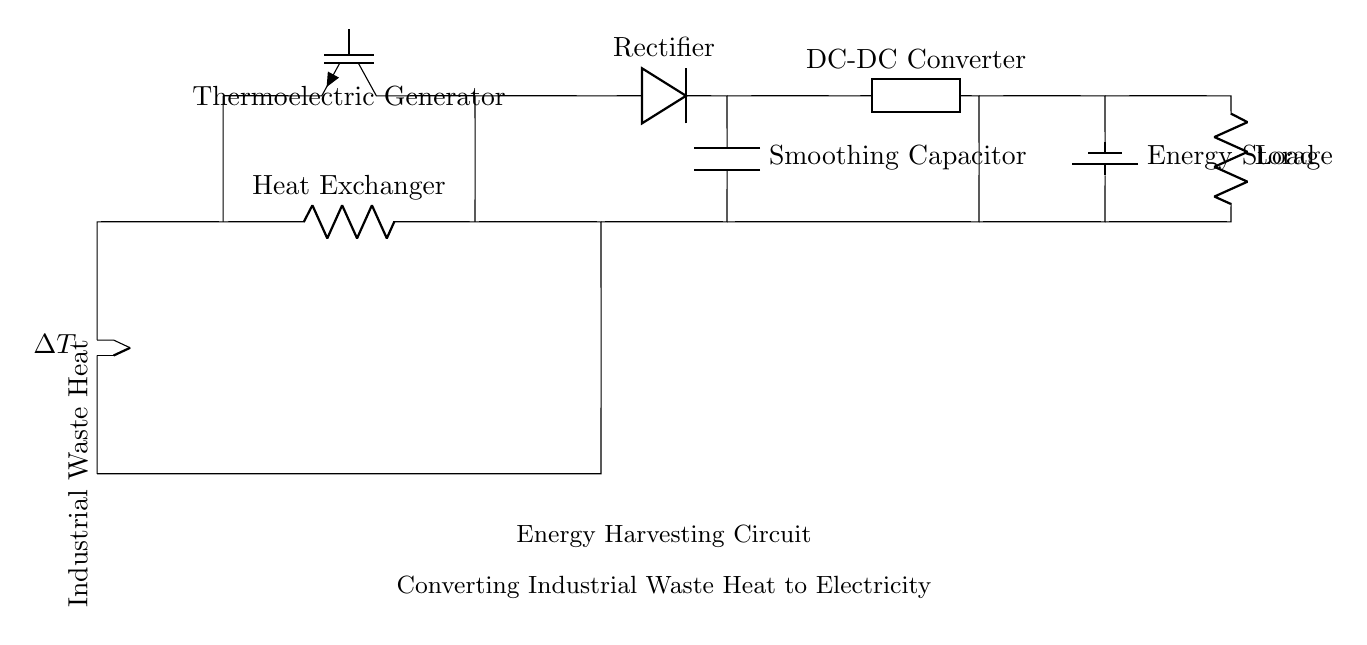What is the primary energy source for this circuit? The primary energy source is industrial waste heat, indicated by the label "Industrial Waste Heat" connected to the thermocouple.
Answer: industrial waste heat What component converts heat into electricity? The component that converts heat into electricity is the thermoelectric generator, which is labeled as such in the circuit.
Answer: thermoelectric generator What is the role of the rectifier in this circuit? The rectifier's role is to convert the alternating current generated by the thermoelectric generator into direct current, as indicated by its label in the circuit diagram.
Answer: convert AC to DC Which component is used for energy storage? The energy storage component is labeled as "Energy Storage" and is represented by a battery in the circuit, which stores the generated electricity.
Answer: battery How does the circuit ensure a stable output voltage? The circuit ensures stable output voltage by using a smoothing capacitor after the rectifier to reduce voltage ripple, as seen by the capacitor labeled in the diagram.
Answer: smoothing capacitor What is the function of the DC-DC converter in this setup? The DC-DC converter's function is to adjust the voltage level of the direct current coming from the rectifier, ensuring the load receives the correct voltage, as indicated in the circuit.
Answer: adjust voltage level What happens to the electricity after passing through the load? After passing through the load, the electricity is used by the load component, which typically represents any device that requires electrical power, as shown in the diagram.
Answer: used by load 